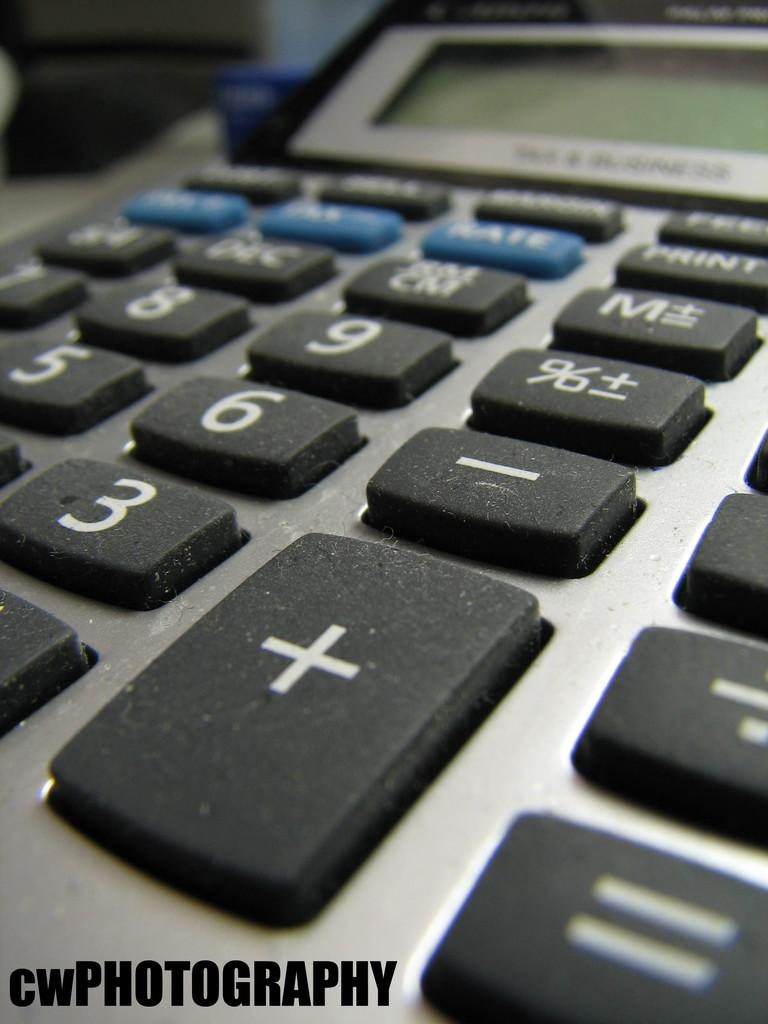<image>
Share a concise interpretation of the image provided. a close up of the keys for a calculator by CW Photography 